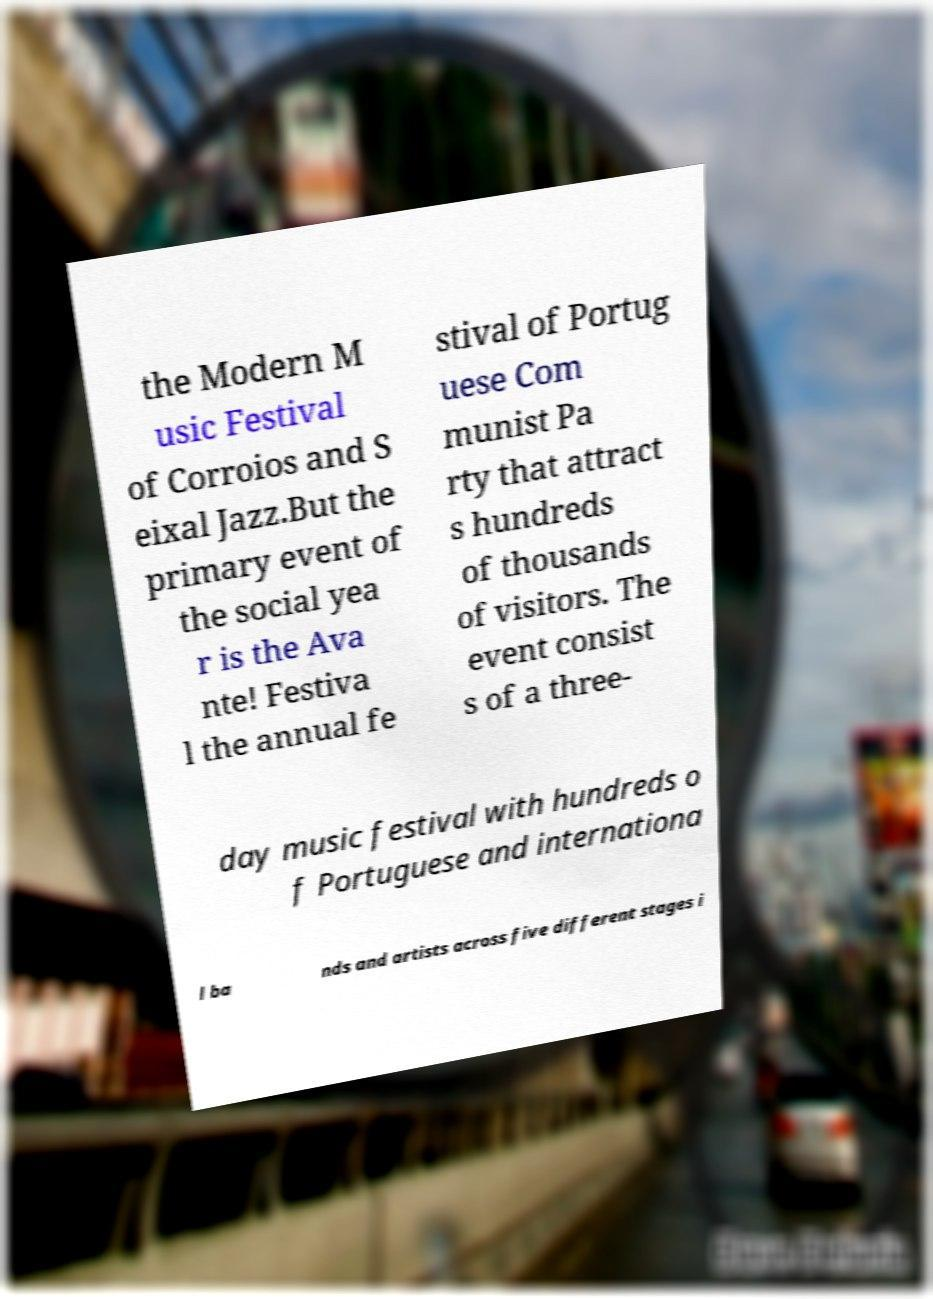Please read and relay the text visible in this image. What does it say? the Modern M usic Festival of Corroios and S eixal Jazz.But the primary event of the social yea r is the Ava nte! Festiva l the annual fe stival of Portug uese Com munist Pa rty that attract s hundreds of thousands of visitors. The event consist s of a three- day music festival with hundreds o f Portuguese and internationa l ba nds and artists across five different stages i 